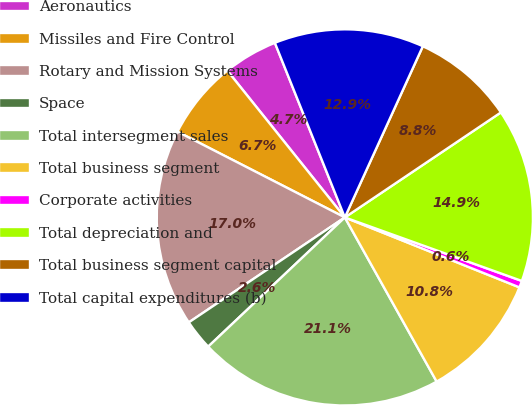<chart> <loc_0><loc_0><loc_500><loc_500><pie_chart><fcel>Aeronautics<fcel>Missiles and Fire Control<fcel>Rotary and Mission Systems<fcel>Space<fcel>Total intersegment sales<fcel>Total business segment<fcel>Corporate activities<fcel>Total depreciation and<fcel>Total business segment capital<fcel>Total capital expenditures (b)<nl><fcel>4.68%<fcel>6.72%<fcel>16.96%<fcel>2.63%<fcel>21.06%<fcel>10.82%<fcel>0.58%<fcel>14.91%<fcel>8.77%<fcel>12.87%<nl></chart> 